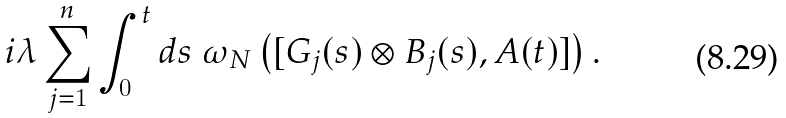Convert formula to latex. <formula><loc_0><loc_0><loc_500><loc_500>i \lambda \sum _ { j = 1 } ^ { n } \int _ { 0 } ^ { t } d s \ \omega _ { N } \left ( [ G _ { j } ( s ) \otimes B _ { j } ( s ) , A ( t ) ] \right ) .</formula> 